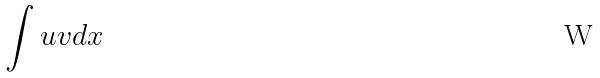Convert formula to latex. <formula><loc_0><loc_0><loc_500><loc_500>\int u v d x</formula> 